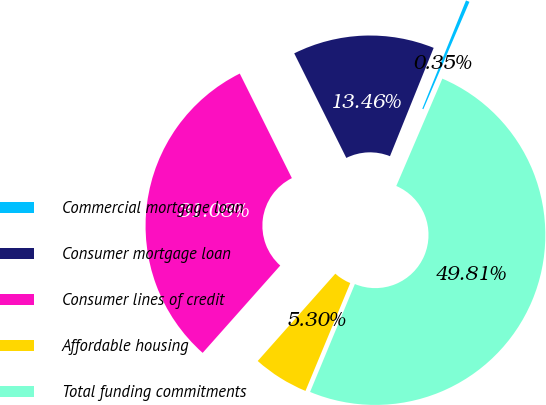<chart> <loc_0><loc_0><loc_500><loc_500><pie_chart><fcel>Commercial mortgage loan<fcel>Consumer mortgage loan<fcel>Consumer lines of credit<fcel>Affordable housing<fcel>Total funding commitments<nl><fcel>0.35%<fcel>13.46%<fcel>31.08%<fcel>5.3%<fcel>49.81%<nl></chart> 